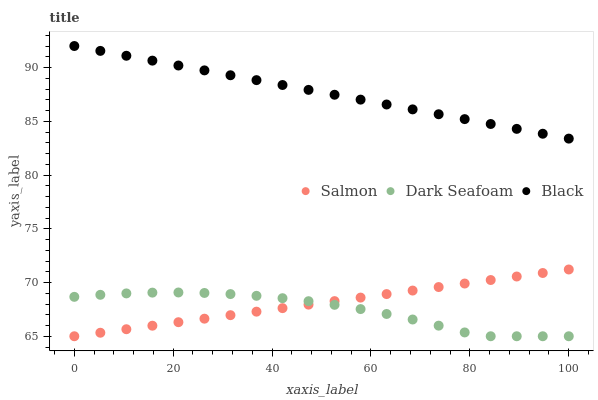Does Dark Seafoam have the minimum area under the curve?
Answer yes or no. Yes. Does Black have the maximum area under the curve?
Answer yes or no. Yes. Does Salmon have the minimum area under the curve?
Answer yes or no. No. Does Salmon have the maximum area under the curve?
Answer yes or no. No. Is Salmon the smoothest?
Answer yes or no. Yes. Is Dark Seafoam the roughest?
Answer yes or no. Yes. Is Dark Seafoam the smoothest?
Answer yes or no. No. Is Salmon the roughest?
Answer yes or no. No. Does Dark Seafoam have the lowest value?
Answer yes or no. Yes. Does Black have the highest value?
Answer yes or no. Yes. Does Salmon have the highest value?
Answer yes or no. No. Is Dark Seafoam less than Black?
Answer yes or no. Yes. Is Black greater than Dark Seafoam?
Answer yes or no. Yes. Does Dark Seafoam intersect Salmon?
Answer yes or no. Yes. Is Dark Seafoam less than Salmon?
Answer yes or no. No. Is Dark Seafoam greater than Salmon?
Answer yes or no. No. Does Dark Seafoam intersect Black?
Answer yes or no. No. 